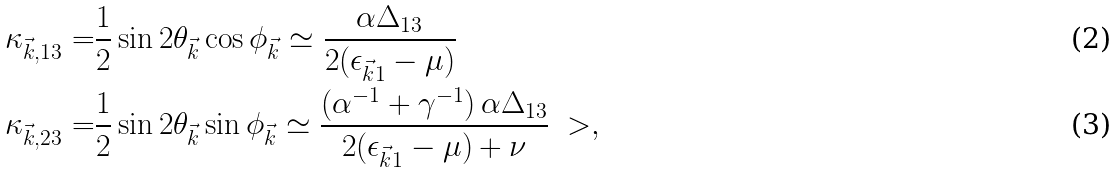<formula> <loc_0><loc_0><loc_500><loc_500>\kappa _ { \vec { k } , 1 3 } = & \frac { 1 } { 2 } \sin 2 \theta _ { \vec { k } } \cos \phi _ { \vec { k } } \simeq \frac { \alpha \Delta _ { 1 3 } } { 2 ( \epsilon _ { \vec { k } 1 } - \mu ) } \\ \kappa _ { \vec { k } , 2 3 } = & \frac { 1 } { 2 } \sin 2 \theta _ { \vec { k } } \sin \phi _ { \vec { k } } \simeq \frac { ( \alpha ^ { - 1 } + \gamma ^ { - 1 } ) \, \alpha \Delta _ { 1 3 } } { 2 ( \epsilon _ { \vec { k } 1 } - \mu ) + \nu } \ > ,</formula> 